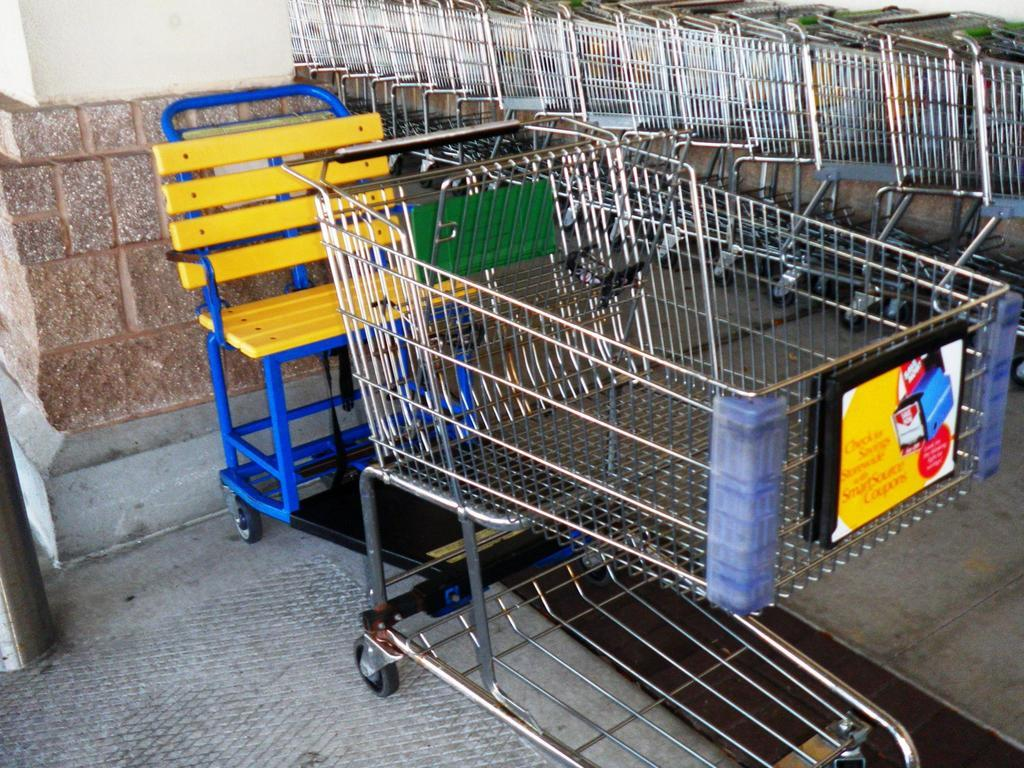What is located in the foreground of the image? There is a trolley and a chair in the foreground of the image. Can you describe the background of the image? There is a group of trolleys in the background of the image. What is visible on the left side of the image? There is a wall on the left side of the image. What is visible at the bottom of the image? There is a floor visible at the bottom of the image. Can you see any underwear hanging on the wall in the image? There is no underwear visible in the image; only a trolley, a chair, a wall, and a floor are present. What is the group of trolleys wishing for in the background of the image? There is no indication of any wishes or desires in the image; it simply shows a group of trolleys in the background. 